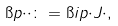Convert formula to latex. <formula><loc_0><loc_0><loc_500><loc_500>\i p { \cdot } { \cdot } \colon = \i i p { \cdot } { J \cdot } ,</formula> 